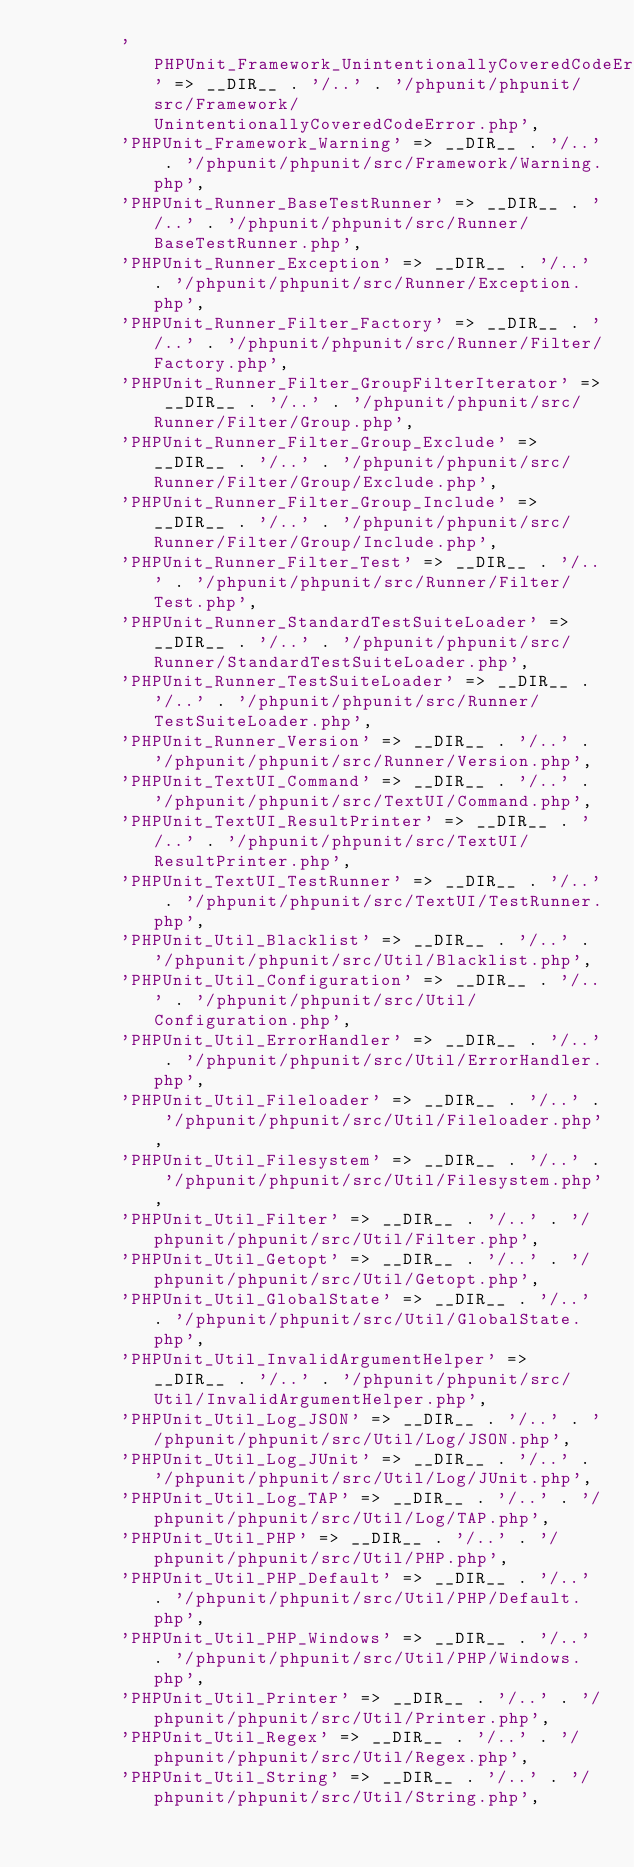<code> <loc_0><loc_0><loc_500><loc_500><_PHP_>        'PHPUnit_Framework_UnintentionallyCoveredCodeError' => __DIR__ . '/..' . '/phpunit/phpunit/src/Framework/UnintentionallyCoveredCodeError.php',
        'PHPUnit_Framework_Warning' => __DIR__ . '/..' . '/phpunit/phpunit/src/Framework/Warning.php',
        'PHPUnit_Runner_BaseTestRunner' => __DIR__ . '/..' . '/phpunit/phpunit/src/Runner/BaseTestRunner.php',
        'PHPUnit_Runner_Exception' => __DIR__ . '/..' . '/phpunit/phpunit/src/Runner/Exception.php',
        'PHPUnit_Runner_Filter_Factory' => __DIR__ . '/..' . '/phpunit/phpunit/src/Runner/Filter/Factory.php',
        'PHPUnit_Runner_Filter_GroupFilterIterator' => __DIR__ . '/..' . '/phpunit/phpunit/src/Runner/Filter/Group.php',
        'PHPUnit_Runner_Filter_Group_Exclude' => __DIR__ . '/..' . '/phpunit/phpunit/src/Runner/Filter/Group/Exclude.php',
        'PHPUnit_Runner_Filter_Group_Include' => __DIR__ . '/..' . '/phpunit/phpunit/src/Runner/Filter/Group/Include.php',
        'PHPUnit_Runner_Filter_Test' => __DIR__ . '/..' . '/phpunit/phpunit/src/Runner/Filter/Test.php',
        'PHPUnit_Runner_StandardTestSuiteLoader' => __DIR__ . '/..' . '/phpunit/phpunit/src/Runner/StandardTestSuiteLoader.php',
        'PHPUnit_Runner_TestSuiteLoader' => __DIR__ . '/..' . '/phpunit/phpunit/src/Runner/TestSuiteLoader.php',
        'PHPUnit_Runner_Version' => __DIR__ . '/..' . '/phpunit/phpunit/src/Runner/Version.php',
        'PHPUnit_TextUI_Command' => __DIR__ . '/..' . '/phpunit/phpunit/src/TextUI/Command.php',
        'PHPUnit_TextUI_ResultPrinter' => __DIR__ . '/..' . '/phpunit/phpunit/src/TextUI/ResultPrinter.php',
        'PHPUnit_TextUI_TestRunner' => __DIR__ . '/..' . '/phpunit/phpunit/src/TextUI/TestRunner.php',
        'PHPUnit_Util_Blacklist' => __DIR__ . '/..' . '/phpunit/phpunit/src/Util/Blacklist.php',
        'PHPUnit_Util_Configuration' => __DIR__ . '/..' . '/phpunit/phpunit/src/Util/Configuration.php',
        'PHPUnit_Util_ErrorHandler' => __DIR__ . '/..' . '/phpunit/phpunit/src/Util/ErrorHandler.php',
        'PHPUnit_Util_Fileloader' => __DIR__ . '/..' . '/phpunit/phpunit/src/Util/Fileloader.php',
        'PHPUnit_Util_Filesystem' => __DIR__ . '/..' . '/phpunit/phpunit/src/Util/Filesystem.php',
        'PHPUnit_Util_Filter' => __DIR__ . '/..' . '/phpunit/phpunit/src/Util/Filter.php',
        'PHPUnit_Util_Getopt' => __DIR__ . '/..' . '/phpunit/phpunit/src/Util/Getopt.php',
        'PHPUnit_Util_GlobalState' => __DIR__ . '/..' . '/phpunit/phpunit/src/Util/GlobalState.php',
        'PHPUnit_Util_InvalidArgumentHelper' => __DIR__ . '/..' . '/phpunit/phpunit/src/Util/InvalidArgumentHelper.php',
        'PHPUnit_Util_Log_JSON' => __DIR__ . '/..' . '/phpunit/phpunit/src/Util/Log/JSON.php',
        'PHPUnit_Util_Log_JUnit' => __DIR__ . '/..' . '/phpunit/phpunit/src/Util/Log/JUnit.php',
        'PHPUnit_Util_Log_TAP' => __DIR__ . '/..' . '/phpunit/phpunit/src/Util/Log/TAP.php',
        'PHPUnit_Util_PHP' => __DIR__ . '/..' . '/phpunit/phpunit/src/Util/PHP.php',
        'PHPUnit_Util_PHP_Default' => __DIR__ . '/..' . '/phpunit/phpunit/src/Util/PHP/Default.php',
        'PHPUnit_Util_PHP_Windows' => __DIR__ . '/..' . '/phpunit/phpunit/src/Util/PHP/Windows.php',
        'PHPUnit_Util_Printer' => __DIR__ . '/..' . '/phpunit/phpunit/src/Util/Printer.php',
        'PHPUnit_Util_Regex' => __DIR__ . '/..' . '/phpunit/phpunit/src/Util/Regex.php',
        'PHPUnit_Util_String' => __DIR__ . '/..' . '/phpunit/phpunit/src/Util/String.php',</code> 